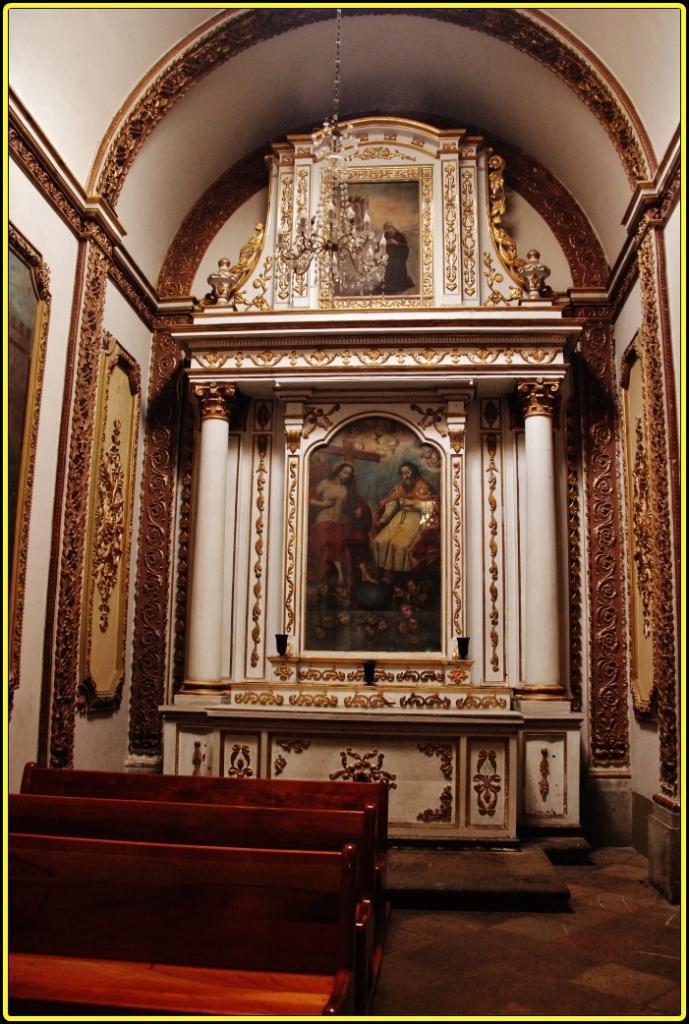Please provide a concise description of this image. In the foreground of this image, at the bottom, there are benches on the floor. In the background, there are few frames like objects to the wall. On either side there is wall. at the top, there is an arch and a chandelier. 